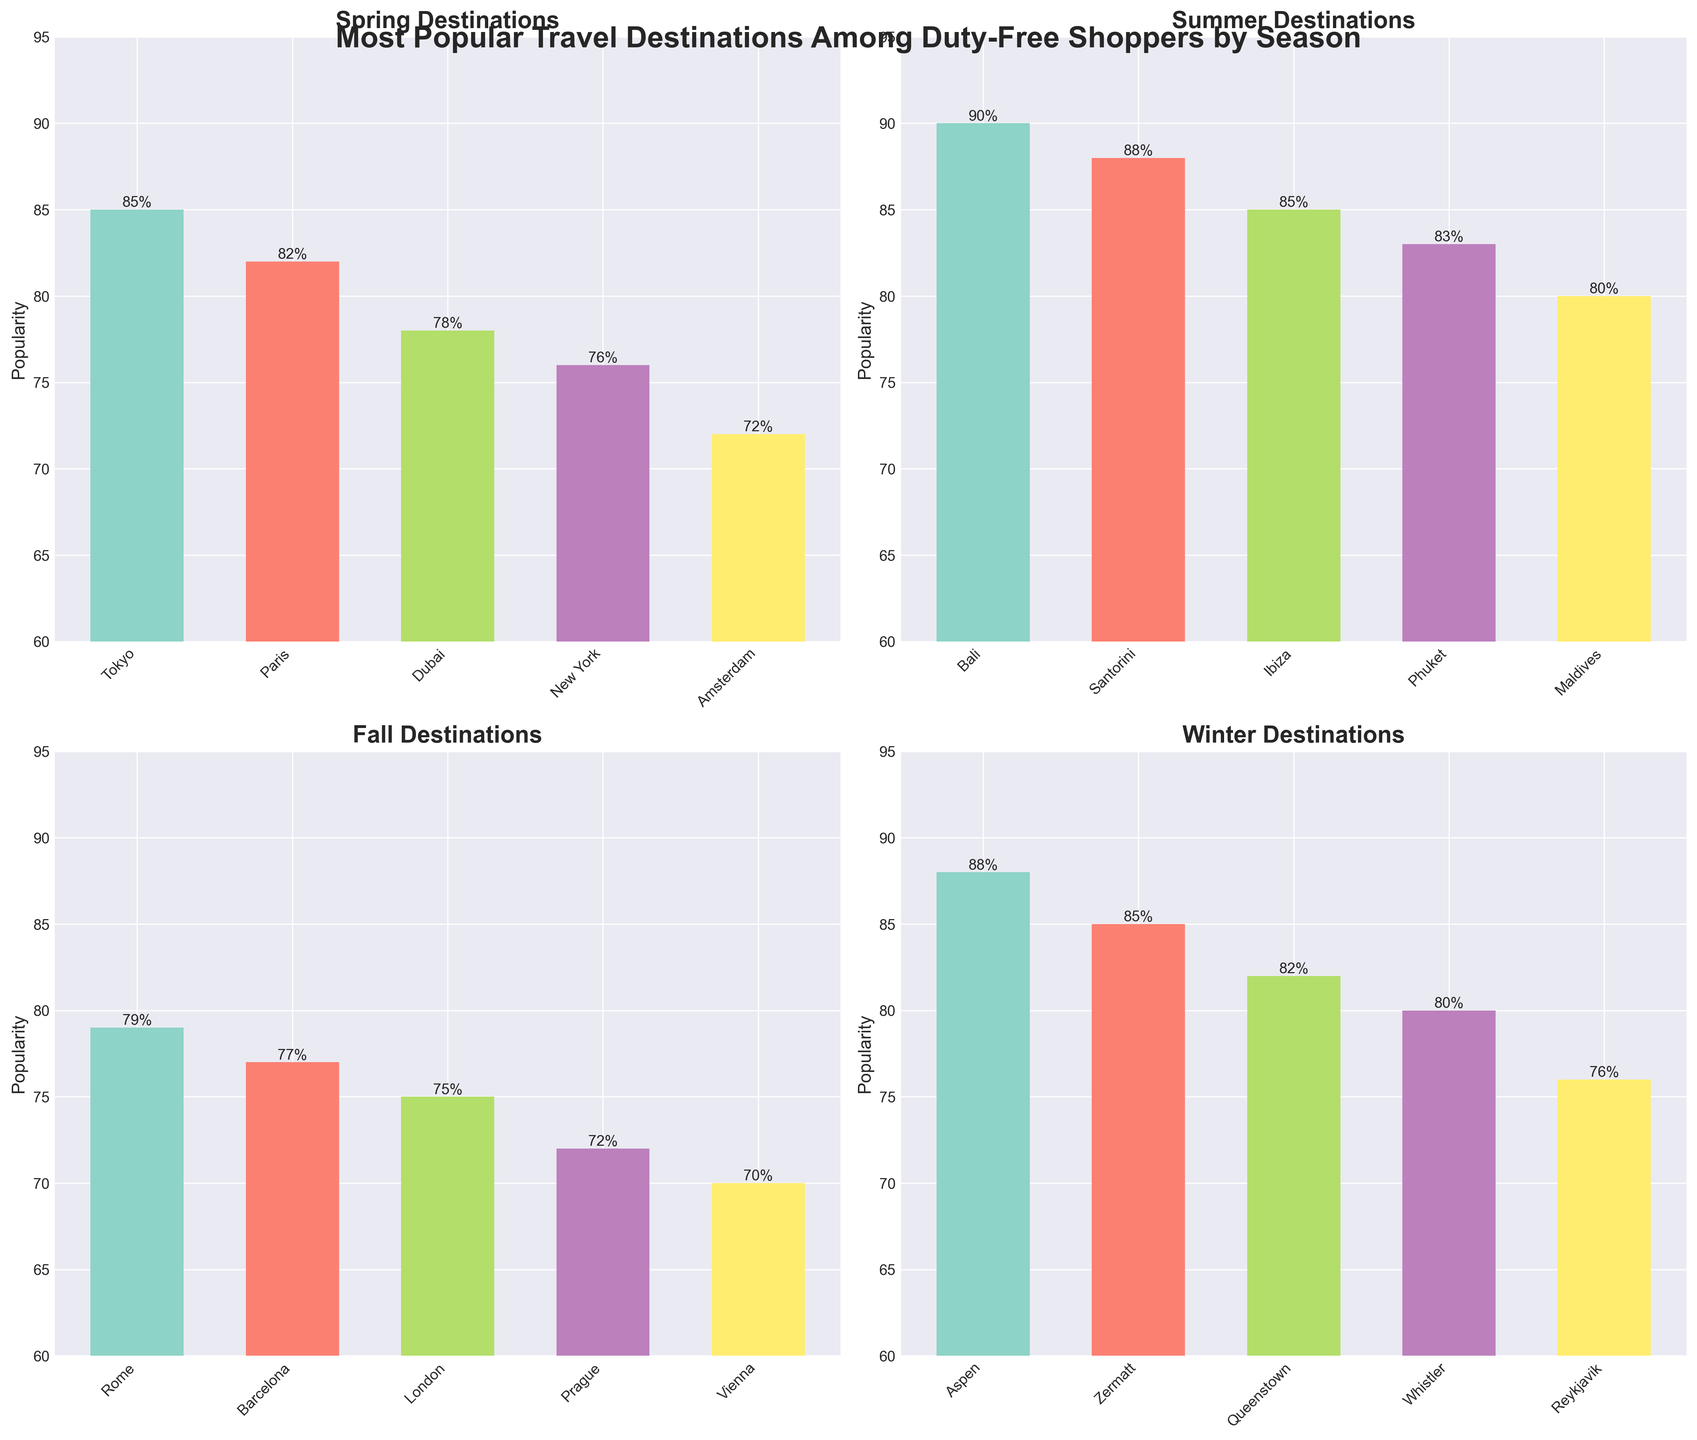Which season shows the highest popularity for the most popular destination? The highest popularity in Spring is 85 for Tokyo, in Summer is 90 for Bali, in Fall is 79 for Rome, and in Winter is 88 for Aspen. The highest value is in Summer with Bali.
Answer: Summer Which destination is the least popular in Fall? Look at the Fall panel and identify the shortest bar, which is for Vienna with a popularity of 70.
Answer: Vienna What is the overall average popularity for all Spring destinations? Sum the popularities of Spring destinations: 85 + 82 + 78 + 76 + 72 = 393. Divide by the number of destinations, which is 5: 393 / 5 = 78.6
Answer: 78.6 Is Paris more popular in Spring than Queenstown in Winter? Compare the heights of the bars for Paris in Spring (82) and Queenstown in Winter (82). Paris (82) and Queenstown (82) have equal popularity.
Answer: Equal How much more popular is the top Summer destination compared to the top Fall destination? The top Summer destination (Bali) has a popularity of 90, and the top Fall destination (Rome) has a popularity of 79. Calculate the difference: 90 - 79 = 11
Answer: 11 Which destination has a popularity closest to 80 in Winter? In Winter, the bar with popularity closest to 80 is Whistler with a popularity of 80.
Answer: Whistler Which season has the least variation in destination popularity? Observing the range of popularities for each season, Spring has a range of 72 to 85, Summer has 80 to 90, Fall has 70 to 79, and Winter has 76 to 88. Fall has the smallest range (9) indicating the least variation.
Answer: Fall What is the combined popularity of the top destinations in each season? Sum the highest popularity value from each season: Spring (85 for Tokyo), Summer (90 for Bali), Fall (79 for Rome), Winter (88 for Aspen). The combined total is 85 + 90 + 79 + 88 = 342.
Answer: 342 Between Summer and Winter, which season has more destinations with popularity above 85? For Summer, Bali (90), Santorini (88), and Ibiza (85) are above 85. For Winter, Aspen (88) and Zermatt (85) are above 85. Summer has 3, Winter has 2 destinations.
Answer: Summer 